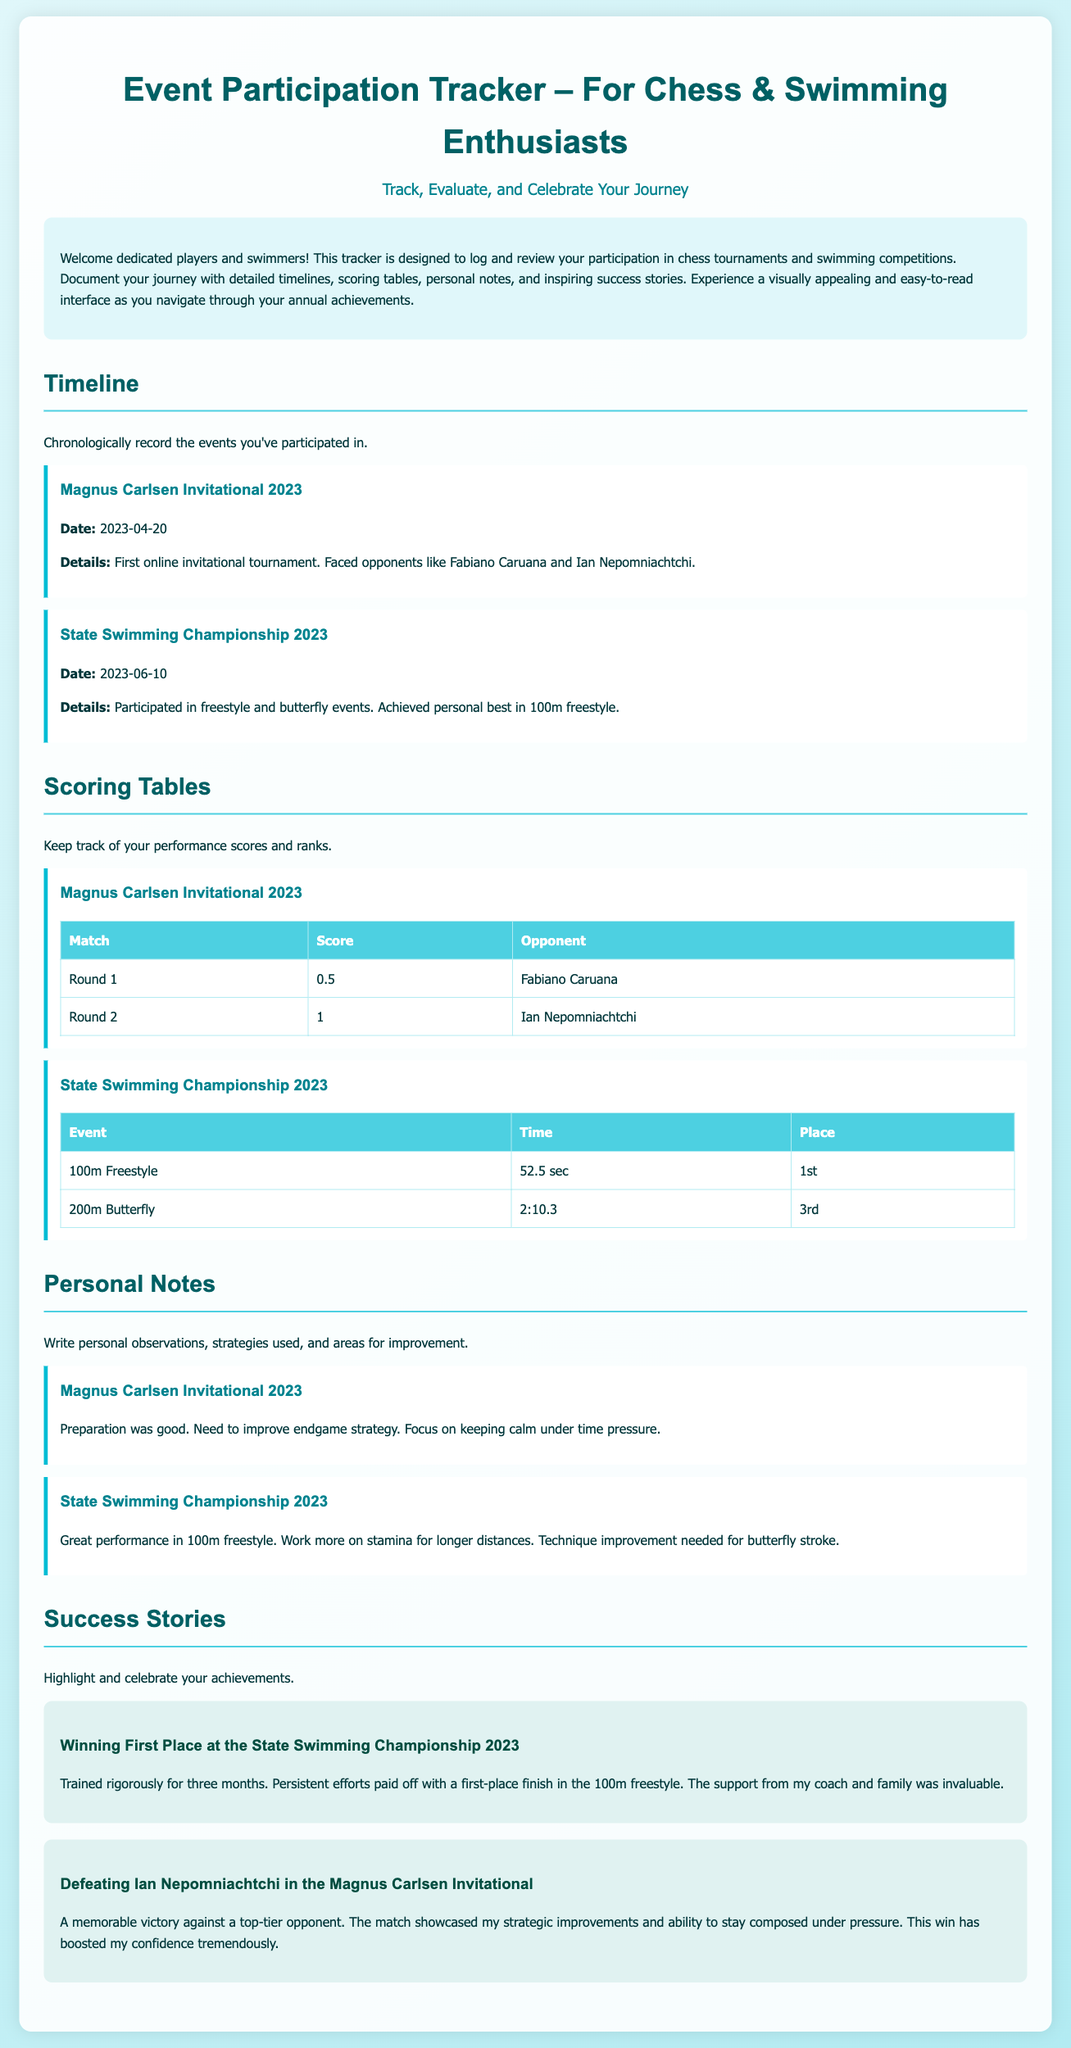what is the title of the tracker? The title of the tracker is mentioned at the top of the document in large font.
Answer: Event Participation Tracker – For Chess & Swimming Enthusiasts when did the Magnus Carlsen Invitational take place? The date for the Magnus Carlsen Invitational is provided in the timeline section of the document.
Answer: 2023-04-20 how did the participant perform in the 100m freestyle event? The performance details are listed in the scoring table for the State Swimming Championship under the 100m freestyle event.
Answer: 1st what was noted as an area of improvement for chess? The personal notes section details specific observations and areas for improvement for the chess tournament.
Answer: Endgame strategy who was the opponent defeated in the Magnus Carlsen Invitational? The success story mentions the opponent defeated during that particular tournament.
Answer: Ian Nepomniachtchi which swimming event had a time of 2:10.3? The scoring table lists all events and their corresponding times; this specific time corresponds to one of the events.
Answer: 200m Butterfly how many months did the participant train for the State Swimming Championship? The success story provides insights about the training duration for the championship.
Answer: Three months what is the main theme of the Event Participation Tracker? The introduction provides a summary of the primary purpose of the tracker.
Answer: Track, Evaluate, and Celebrate Your Journey 